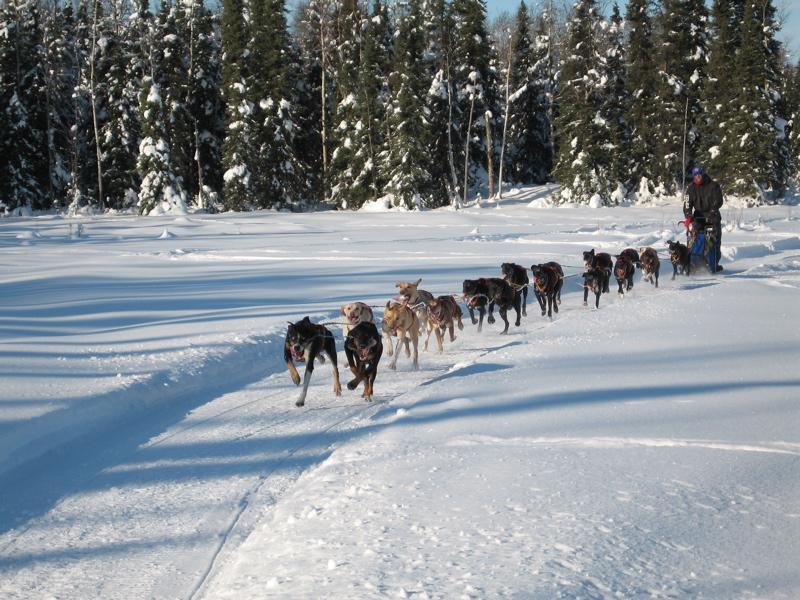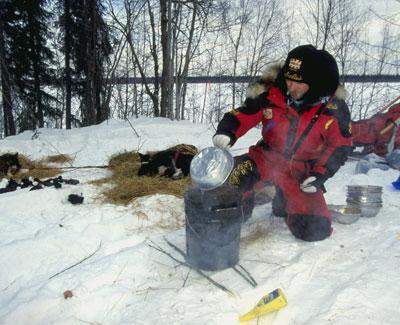The first image is the image on the left, the second image is the image on the right. For the images shown, is this caption "Only one of the images shows a team of dogs pulling a sled." true? Answer yes or no. Yes. The first image is the image on the left, the second image is the image on the right. Evaluate the accuracy of this statement regarding the images: "One image shows a sled dog team moving down a path in the snow, and the other image shows sled dogs that are not hitched or working.". Is it true? Answer yes or no. Yes. 